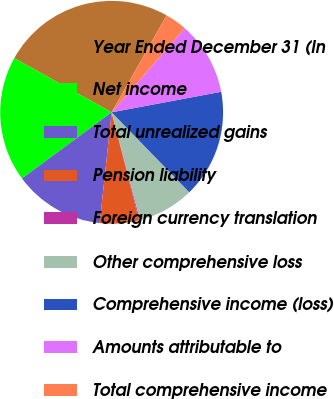Convert chart to OTSL. <chart><loc_0><loc_0><loc_500><loc_500><pie_chart><fcel>Year Ended December 31 (In<fcel>Net income<fcel>Total unrealized gains<fcel>Pension liability<fcel>Foreign currency translation<fcel>Other comprehensive loss<fcel>Comprehensive income (loss)<fcel>Amounts attributable to<fcel>Total comprehensive income<nl><fcel>25.14%<fcel>18.18%<fcel>13.17%<fcel>5.67%<fcel>0.14%<fcel>8.17%<fcel>15.68%<fcel>10.67%<fcel>3.17%<nl></chart> 